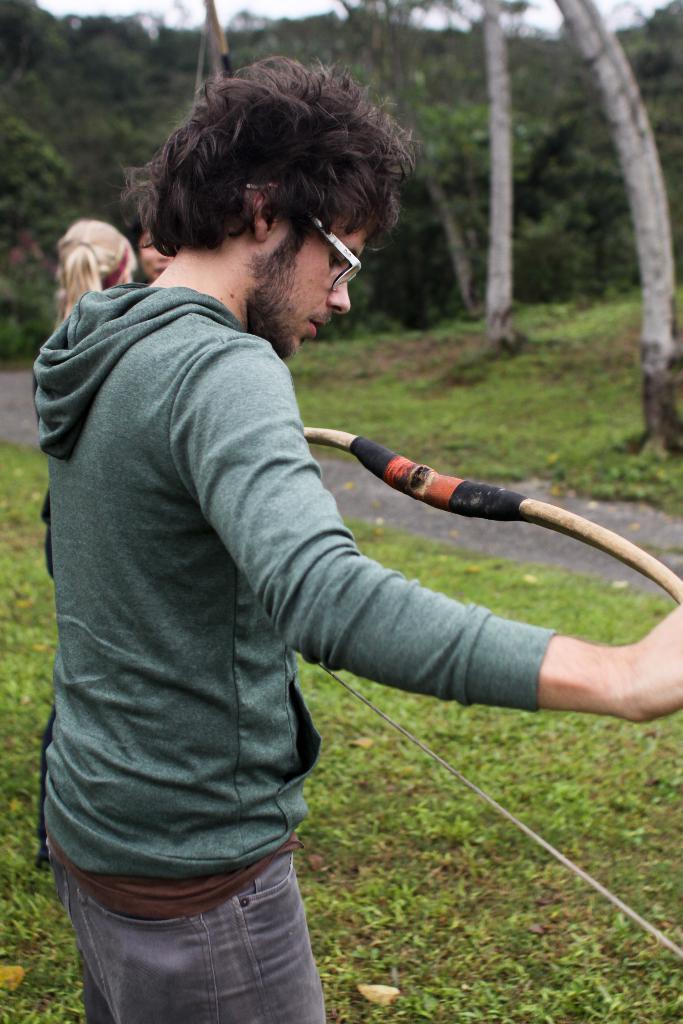Please provide a concise description of this image. In this image we can see there is a person standing on the surface of the grass and he is holding an arrow in his hand, beside the person there are two girls standing. In the background there are trees. 